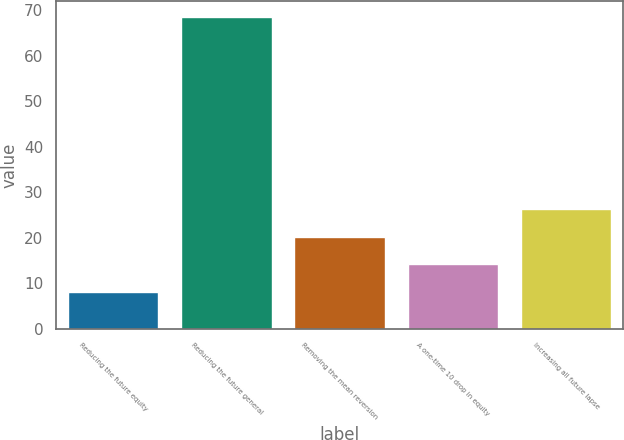<chart> <loc_0><loc_0><loc_500><loc_500><bar_chart><fcel>Reducing the future equity<fcel>Reducing the future general<fcel>Removing the mean reversion<fcel>A one-time 10 drop in equity<fcel>Increasing all future lapse<nl><fcel>8.2<fcel>68.6<fcel>20.28<fcel>14.24<fcel>26.32<nl></chart> 